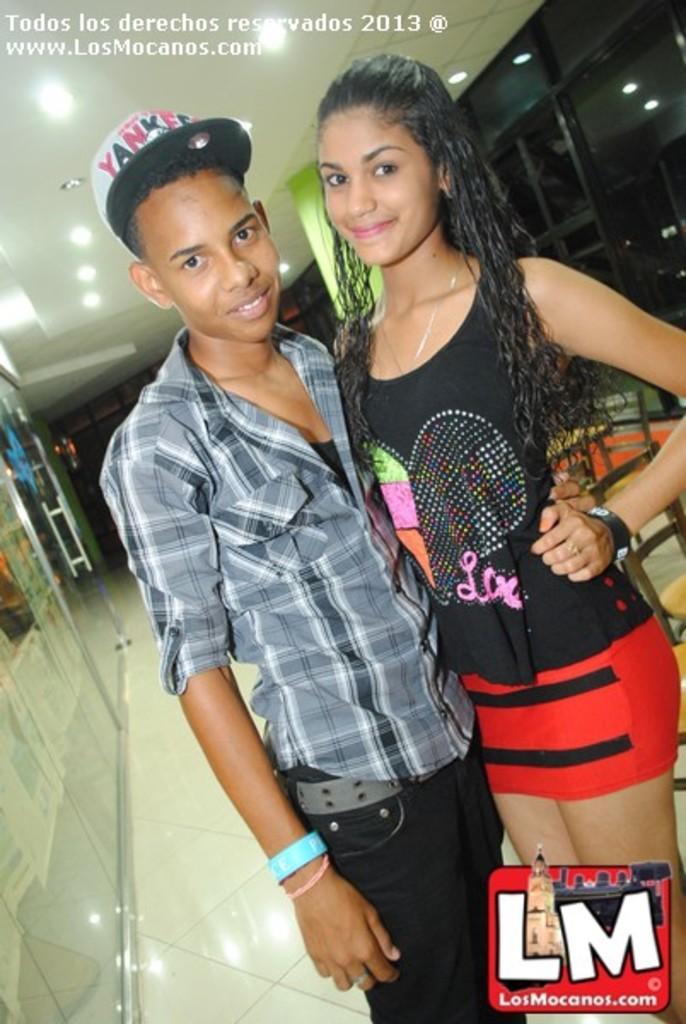Describe this image in one or two sentences. In this image in the foreground I can see two people, on the left side side I can see a door and at the top there are some lights and a person on the left side wearing a cap. 